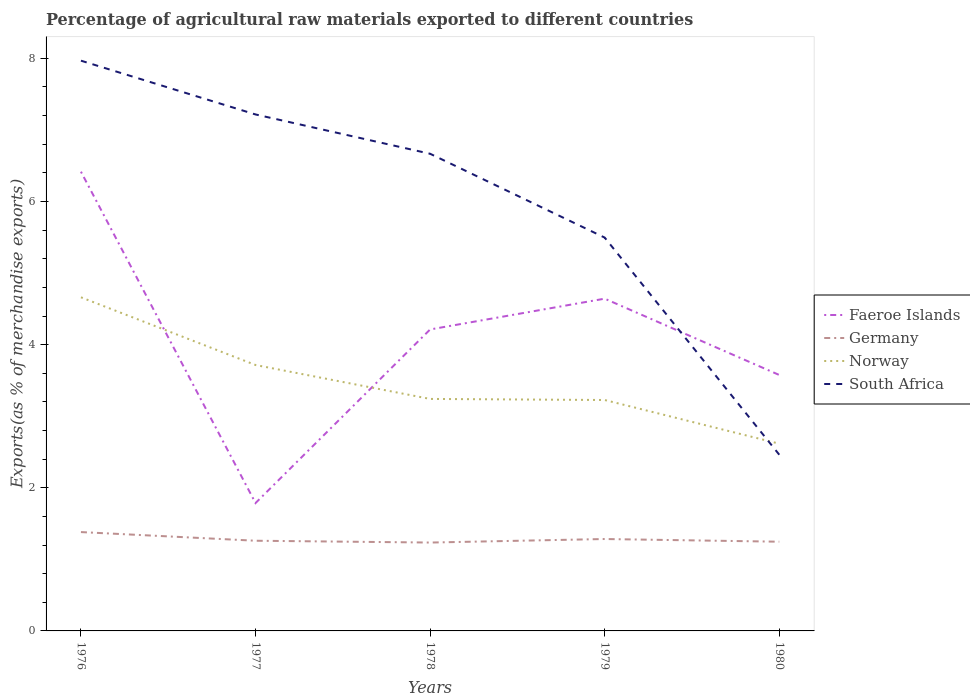How many different coloured lines are there?
Ensure brevity in your answer.  4. Is the number of lines equal to the number of legend labels?
Make the answer very short. Yes. Across all years, what is the maximum percentage of exports to different countries in Germany?
Keep it short and to the point. 1.23. What is the total percentage of exports to different countries in Germany in the graph?
Offer a terse response. -0.05. What is the difference between the highest and the second highest percentage of exports to different countries in Germany?
Offer a very short reply. 0.15. How many lines are there?
Give a very brief answer. 4. How many years are there in the graph?
Provide a succinct answer. 5. Where does the legend appear in the graph?
Offer a very short reply. Center right. How many legend labels are there?
Offer a very short reply. 4. How are the legend labels stacked?
Give a very brief answer. Vertical. What is the title of the graph?
Keep it short and to the point. Percentage of agricultural raw materials exported to different countries. What is the label or title of the X-axis?
Give a very brief answer. Years. What is the label or title of the Y-axis?
Provide a succinct answer. Exports(as % of merchandise exports). What is the Exports(as % of merchandise exports) of Faeroe Islands in 1976?
Your answer should be compact. 6.42. What is the Exports(as % of merchandise exports) of Germany in 1976?
Provide a short and direct response. 1.38. What is the Exports(as % of merchandise exports) in Norway in 1976?
Provide a succinct answer. 4.66. What is the Exports(as % of merchandise exports) of South Africa in 1976?
Offer a very short reply. 7.97. What is the Exports(as % of merchandise exports) of Faeroe Islands in 1977?
Keep it short and to the point. 1.79. What is the Exports(as % of merchandise exports) in Germany in 1977?
Your answer should be compact. 1.26. What is the Exports(as % of merchandise exports) in Norway in 1977?
Your answer should be very brief. 3.72. What is the Exports(as % of merchandise exports) in South Africa in 1977?
Your answer should be very brief. 7.22. What is the Exports(as % of merchandise exports) in Faeroe Islands in 1978?
Provide a succinct answer. 4.21. What is the Exports(as % of merchandise exports) of Germany in 1978?
Your answer should be compact. 1.23. What is the Exports(as % of merchandise exports) of Norway in 1978?
Make the answer very short. 3.24. What is the Exports(as % of merchandise exports) in South Africa in 1978?
Offer a terse response. 6.67. What is the Exports(as % of merchandise exports) in Faeroe Islands in 1979?
Your answer should be compact. 4.64. What is the Exports(as % of merchandise exports) of Germany in 1979?
Your answer should be very brief. 1.28. What is the Exports(as % of merchandise exports) of Norway in 1979?
Offer a terse response. 3.23. What is the Exports(as % of merchandise exports) of South Africa in 1979?
Provide a short and direct response. 5.5. What is the Exports(as % of merchandise exports) in Faeroe Islands in 1980?
Your answer should be very brief. 3.58. What is the Exports(as % of merchandise exports) in Germany in 1980?
Offer a terse response. 1.25. What is the Exports(as % of merchandise exports) in Norway in 1980?
Provide a short and direct response. 2.62. What is the Exports(as % of merchandise exports) in South Africa in 1980?
Your answer should be very brief. 2.46. Across all years, what is the maximum Exports(as % of merchandise exports) of Faeroe Islands?
Give a very brief answer. 6.42. Across all years, what is the maximum Exports(as % of merchandise exports) of Germany?
Your answer should be very brief. 1.38. Across all years, what is the maximum Exports(as % of merchandise exports) in Norway?
Ensure brevity in your answer.  4.66. Across all years, what is the maximum Exports(as % of merchandise exports) in South Africa?
Provide a succinct answer. 7.97. Across all years, what is the minimum Exports(as % of merchandise exports) of Faeroe Islands?
Provide a short and direct response. 1.79. Across all years, what is the minimum Exports(as % of merchandise exports) of Germany?
Offer a very short reply. 1.23. Across all years, what is the minimum Exports(as % of merchandise exports) in Norway?
Make the answer very short. 2.62. Across all years, what is the minimum Exports(as % of merchandise exports) of South Africa?
Provide a succinct answer. 2.46. What is the total Exports(as % of merchandise exports) of Faeroe Islands in the graph?
Your response must be concise. 20.63. What is the total Exports(as % of merchandise exports) in Germany in the graph?
Give a very brief answer. 6.41. What is the total Exports(as % of merchandise exports) in Norway in the graph?
Provide a succinct answer. 17.46. What is the total Exports(as % of merchandise exports) in South Africa in the graph?
Give a very brief answer. 29.81. What is the difference between the Exports(as % of merchandise exports) in Faeroe Islands in 1976 and that in 1977?
Offer a terse response. 4.63. What is the difference between the Exports(as % of merchandise exports) of Germany in 1976 and that in 1977?
Keep it short and to the point. 0.12. What is the difference between the Exports(as % of merchandise exports) of Norway in 1976 and that in 1977?
Offer a terse response. 0.95. What is the difference between the Exports(as % of merchandise exports) in South Africa in 1976 and that in 1977?
Your response must be concise. 0.75. What is the difference between the Exports(as % of merchandise exports) of Faeroe Islands in 1976 and that in 1978?
Give a very brief answer. 2.2. What is the difference between the Exports(as % of merchandise exports) of Germany in 1976 and that in 1978?
Give a very brief answer. 0.15. What is the difference between the Exports(as % of merchandise exports) in Norway in 1976 and that in 1978?
Offer a terse response. 1.42. What is the difference between the Exports(as % of merchandise exports) in South Africa in 1976 and that in 1978?
Provide a succinct answer. 1.3. What is the difference between the Exports(as % of merchandise exports) of Faeroe Islands in 1976 and that in 1979?
Make the answer very short. 1.77. What is the difference between the Exports(as % of merchandise exports) of Germany in 1976 and that in 1979?
Give a very brief answer. 0.1. What is the difference between the Exports(as % of merchandise exports) in Norway in 1976 and that in 1979?
Provide a succinct answer. 1.44. What is the difference between the Exports(as % of merchandise exports) of South Africa in 1976 and that in 1979?
Keep it short and to the point. 2.47. What is the difference between the Exports(as % of merchandise exports) in Faeroe Islands in 1976 and that in 1980?
Give a very brief answer. 2.84. What is the difference between the Exports(as % of merchandise exports) in Germany in 1976 and that in 1980?
Provide a succinct answer. 0.13. What is the difference between the Exports(as % of merchandise exports) in Norway in 1976 and that in 1980?
Your response must be concise. 2.05. What is the difference between the Exports(as % of merchandise exports) in South Africa in 1976 and that in 1980?
Your answer should be compact. 5.51. What is the difference between the Exports(as % of merchandise exports) of Faeroe Islands in 1977 and that in 1978?
Your answer should be compact. -2.43. What is the difference between the Exports(as % of merchandise exports) in Germany in 1977 and that in 1978?
Keep it short and to the point. 0.03. What is the difference between the Exports(as % of merchandise exports) of Norway in 1977 and that in 1978?
Provide a succinct answer. 0.47. What is the difference between the Exports(as % of merchandise exports) of South Africa in 1977 and that in 1978?
Your answer should be very brief. 0.55. What is the difference between the Exports(as % of merchandise exports) in Faeroe Islands in 1977 and that in 1979?
Your answer should be compact. -2.86. What is the difference between the Exports(as % of merchandise exports) in Germany in 1977 and that in 1979?
Your response must be concise. -0.02. What is the difference between the Exports(as % of merchandise exports) in Norway in 1977 and that in 1979?
Offer a very short reply. 0.49. What is the difference between the Exports(as % of merchandise exports) in South Africa in 1977 and that in 1979?
Offer a terse response. 1.72. What is the difference between the Exports(as % of merchandise exports) of Faeroe Islands in 1977 and that in 1980?
Your answer should be compact. -1.79. What is the difference between the Exports(as % of merchandise exports) in Germany in 1977 and that in 1980?
Offer a terse response. 0.01. What is the difference between the Exports(as % of merchandise exports) in Norway in 1977 and that in 1980?
Provide a succinct answer. 1.1. What is the difference between the Exports(as % of merchandise exports) in South Africa in 1977 and that in 1980?
Provide a succinct answer. 4.75. What is the difference between the Exports(as % of merchandise exports) of Faeroe Islands in 1978 and that in 1979?
Keep it short and to the point. -0.43. What is the difference between the Exports(as % of merchandise exports) in Germany in 1978 and that in 1979?
Keep it short and to the point. -0.05. What is the difference between the Exports(as % of merchandise exports) in Norway in 1978 and that in 1979?
Make the answer very short. 0.02. What is the difference between the Exports(as % of merchandise exports) of South Africa in 1978 and that in 1979?
Your answer should be compact. 1.17. What is the difference between the Exports(as % of merchandise exports) of Faeroe Islands in 1978 and that in 1980?
Give a very brief answer. 0.64. What is the difference between the Exports(as % of merchandise exports) of Germany in 1978 and that in 1980?
Your answer should be compact. -0.01. What is the difference between the Exports(as % of merchandise exports) in Norway in 1978 and that in 1980?
Your answer should be very brief. 0.63. What is the difference between the Exports(as % of merchandise exports) in South Africa in 1978 and that in 1980?
Give a very brief answer. 4.21. What is the difference between the Exports(as % of merchandise exports) in Faeroe Islands in 1979 and that in 1980?
Your answer should be very brief. 1.07. What is the difference between the Exports(as % of merchandise exports) in Germany in 1979 and that in 1980?
Make the answer very short. 0.04. What is the difference between the Exports(as % of merchandise exports) of Norway in 1979 and that in 1980?
Give a very brief answer. 0.61. What is the difference between the Exports(as % of merchandise exports) of South Africa in 1979 and that in 1980?
Offer a very short reply. 3.03. What is the difference between the Exports(as % of merchandise exports) in Faeroe Islands in 1976 and the Exports(as % of merchandise exports) in Germany in 1977?
Your answer should be compact. 5.16. What is the difference between the Exports(as % of merchandise exports) of Faeroe Islands in 1976 and the Exports(as % of merchandise exports) of Norway in 1977?
Provide a short and direct response. 2.7. What is the difference between the Exports(as % of merchandise exports) in Faeroe Islands in 1976 and the Exports(as % of merchandise exports) in South Africa in 1977?
Provide a short and direct response. -0.8. What is the difference between the Exports(as % of merchandise exports) in Germany in 1976 and the Exports(as % of merchandise exports) in Norway in 1977?
Your answer should be compact. -2.33. What is the difference between the Exports(as % of merchandise exports) in Germany in 1976 and the Exports(as % of merchandise exports) in South Africa in 1977?
Your response must be concise. -5.84. What is the difference between the Exports(as % of merchandise exports) of Norway in 1976 and the Exports(as % of merchandise exports) of South Africa in 1977?
Offer a terse response. -2.55. What is the difference between the Exports(as % of merchandise exports) of Faeroe Islands in 1976 and the Exports(as % of merchandise exports) of Germany in 1978?
Your answer should be very brief. 5.18. What is the difference between the Exports(as % of merchandise exports) in Faeroe Islands in 1976 and the Exports(as % of merchandise exports) in Norway in 1978?
Offer a very short reply. 3.17. What is the difference between the Exports(as % of merchandise exports) in Faeroe Islands in 1976 and the Exports(as % of merchandise exports) in South Africa in 1978?
Keep it short and to the point. -0.25. What is the difference between the Exports(as % of merchandise exports) in Germany in 1976 and the Exports(as % of merchandise exports) in Norway in 1978?
Give a very brief answer. -1.86. What is the difference between the Exports(as % of merchandise exports) of Germany in 1976 and the Exports(as % of merchandise exports) of South Africa in 1978?
Your response must be concise. -5.29. What is the difference between the Exports(as % of merchandise exports) of Norway in 1976 and the Exports(as % of merchandise exports) of South Africa in 1978?
Provide a succinct answer. -2.01. What is the difference between the Exports(as % of merchandise exports) of Faeroe Islands in 1976 and the Exports(as % of merchandise exports) of Germany in 1979?
Provide a short and direct response. 5.13. What is the difference between the Exports(as % of merchandise exports) in Faeroe Islands in 1976 and the Exports(as % of merchandise exports) in Norway in 1979?
Your response must be concise. 3.19. What is the difference between the Exports(as % of merchandise exports) in Faeroe Islands in 1976 and the Exports(as % of merchandise exports) in South Africa in 1979?
Your response must be concise. 0.92. What is the difference between the Exports(as % of merchandise exports) of Germany in 1976 and the Exports(as % of merchandise exports) of Norway in 1979?
Make the answer very short. -1.85. What is the difference between the Exports(as % of merchandise exports) of Germany in 1976 and the Exports(as % of merchandise exports) of South Africa in 1979?
Give a very brief answer. -4.11. What is the difference between the Exports(as % of merchandise exports) of Norway in 1976 and the Exports(as % of merchandise exports) of South Africa in 1979?
Ensure brevity in your answer.  -0.83. What is the difference between the Exports(as % of merchandise exports) in Faeroe Islands in 1976 and the Exports(as % of merchandise exports) in Germany in 1980?
Ensure brevity in your answer.  5.17. What is the difference between the Exports(as % of merchandise exports) in Faeroe Islands in 1976 and the Exports(as % of merchandise exports) in Norway in 1980?
Keep it short and to the point. 3.8. What is the difference between the Exports(as % of merchandise exports) of Faeroe Islands in 1976 and the Exports(as % of merchandise exports) of South Africa in 1980?
Make the answer very short. 3.95. What is the difference between the Exports(as % of merchandise exports) in Germany in 1976 and the Exports(as % of merchandise exports) in Norway in 1980?
Ensure brevity in your answer.  -1.24. What is the difference between the Exports(as % of merchandise exports) in Germany in 1976 and the Exports(as % of merchandise exports) in South Africa in 1980?
Your answer should be compact. -1.08. What is the difference between the Exports(as % of merchandise exports) in Norway in 1976 and the Exports(as % of merchandise exports) in South Africa in 1980?
Provide a short and direct response. 2.2. What is the difference between the Exports(as % of merchandise exports) of Faeroe Islands in 1977 and the Exports(as % of merchandise exports) of Germany in 1978?
Keep it short and to the point. 0.55. What is the difference between the Exports(as % of merchandise exports) of Faeroe Islands in 1977 and the Exports(as % of merchandise exports) of Norway in 1978?
Your response must be concise. -1.45. What is the difference between the Exports(as % of merchandise exports) in Faeroe Islands in 1977 and the Exports(as % of merchandise exports) in South Africa in 1978?
Make the answer very short. -4.88. What is the difference between the Exports(as % of merchandise exports) in Germany in 1977 and the Exports(as % of merchandise exports) in Norway in 1978?
Ensure brevity in your answer.  -1.98. What is the difference between the Exports(as % of merchandise exports) of Germany in 1977 and the Exports(as % of merchandise exports) of South Africa in 1978?
Your answer should be very brief. -5.41. What is the difference between the Exports(as % of merchandise exports) in Norway in 1977 and the Exports(as % of merchandise exports) in South Africa in 1978?
Provide a succinct answer. -2.95. What is the difference between the Exports(as % of merchandise exports) in Faeroe Islands in 1977 and the Exports(as % of merchandise exports) in Germany in 1979?
Your answer should be very brief. 0.5. What is the difference between the Exports(as % of merchandise exports) of Faeroe Islands in 1977 and the Exports(as % of merchandise exports) of Norway in 1979?
Offer a terse response. -1.44. What is the difference between the Exports(as % of merchandise exports) of Faeroe Islands in 1977 and the Exports(as % of merchandise exports) of South Africa in 1979?
Make the answer very short. -3.71. What is the difference between the Exports(as % of merchandise exports) in Germany in 1977 and the Exports(as % of merchandise exports) in Norway in 1979?
Keep it short and to the point. -1.97. What is the difference between the Exports(as % of merchandise exports) of Germany in 1977 and the Exports(as % of merchandise exports) of South Africa in 1979?
Give a very brief answer. -4.24. What is the difference between the Exports(as % of merchandise exports) of Norway in 1977 and the Exports(as % of merchandise exports) of South Africa in 1979?
Your answer should be compact. -1.78. What is the difference between the Exports(as % of merchandise exports) of Faeroe Islands in 1977 and the Exports(as % of merchandise exports) of Germany in 1980?
Offer a very short reply. 0.54. What is the difference between the Exports(as % of merchandise exports) in Faeroe Islands in 1977 and the Exports(as % of merchandise exports) in Norway in 1980?
Provide a short and direct response. -0.83. What is the difference between the Exports(as % of merchandise exports) of Faeroe Islands in 1977 and the Exports(as % of merchandise exports) of South Africa in 1980?
Give a very brief answer. -0.68. What is the difference between the Exports(as % of merchandise exports) in Germany in 1977 and the Exports(as % of merchandise exports) in Norway in 1980?
Your answer should be compact. -1.36. What is the difference between the Exports(as % of merchandise exports) in Germany in 1977 and the Exports(as % of merchandise exports) in South Africa in 1980?
Make the answer very short. -1.2. What is the difference between the Exports(as % of merchandise exports) in Norway in 1977 and the Exports(as % of merchandise exports) in South Africa in 1980?
Provide a succinct answer. 1.25. What is the difference between the Exports(as % of merchandise exports) in Faeroe Islands in 1978 and the Exports(as % of merchandise exports) in Germany in 1979?
Offer a terse response. 2.93. What is the difference between the Exports(as % of merchandise exports) of Faeroe Islands in 1978 and the Exports(as % of merchandise exports) of Norway in 1979?
Make the answer very short. 0.99. What is the difference between the Exports(as % of merchandise exports) in Faeroe Islands in 1978 and the Exports(as % of merchandise exports) in South Africa in 1979?
Ensure brevity in your answer.  -1.28. What is the difference between the Exports(as % of merchandise exports) in Germany in 1978 and the Exports(as % of merchandise exports) in Norway in 1979?
Make the answer very short. -1.99. What is the difference between the Exports(as % of merchandise exports) of Germany in 1978 and the Exports(as % of merchandise exports) of South Africa in 1979?
Your response must be concise. -4.26. What is the difference between the Exports(as % of merchandise exports) in Norway in 1978 and the Exports(as % of merchandise exports) in South Africa in 1979?
Ensure brevity in your answer.  -2.25. What is the difference between the Exports(as % of merchandise exports) in Faeroe Islands in 1978 and the Exports(as % of merchandise exports) in Germany in 1980?
Provide a short and direct response. 2.97. What is the difference between the Exports(as % of merchandise exports) of Faeroe Islands in 1978 and the Exports(as % of merchandise exports) of Norway in 1980?
Provide a succinct answer. 1.6. What is the difference between the Exports(as % of merchandise exports) of Faeroe Islands in 1978 and the Exports(as % of merchandise exports) of South Africa in 1980?
Ensure brevity in your answer.  1.75. What is the difference between the Exports(as % of merchandise exports) in Germany in 1978 and the Exports(as % of merchandise exports) in Norway in 1980?
Offer a terse response. -1.38. What is the difference between the Exports(as % of merchandise exports) of Germany in 1978 and the Exports(as % of merchandise exports) of South Africa in 1980?
Provide a short and direct response. -1.23. What is the difference between the Exports(as % of merchandise exports) of Norway in 1978 and the Exports(as % of merchandise exports) of South Africa in 1980?
Give a very brief answer. 0.78. What is the difference between the Exports(as % of merchandise exports) in Faeroe Islands in 1979 and the Exports(as % of merchandise exports) in Germany in 1980?
Your answer should be compact. 3.4. What is the difference between the Exports(as % of merchandise exports) in Faeroe Islands in 1979 and the Exports(as % of merchandise exports) in Norway in 1980?
Your answer should be very brief. 2.03. What is the difference between the Exports(as % of merchandise exports) in Faeroe Islands in 1979 and the Exports(as % of merchandise exports) in South Africa in 1980?
Offer a very short reply. 2.18. What is the difference between the Exports(as % of merchandise exports) in Germany in 1979 and the Exports(as % of merchandise exports) in Norway in 1980?
Your answer should be very brief. -1.33. What is the difference between the Exports(as % of merchandise exports) of Germany in 1979 and the Exports(as % of merchandise exports) of South Africa in 1980?
Your answer should be compact. -1.18. What is the difference between the Exports(as % of merchandise exports) in Norway in 1979 and the Exports(as % of merchandise exports) in South Africa in 1980?
Provide a succinct answer. 0.76. What is the average Exports(as % of merchandise exports) in Faeroe Islands per year?
Make the answer very short. 4.13. What is the average Exports(as % of merchandise exports) of Germany per year?
Offer a very short reply. 1.28. What is the average Exports(as % of merchandise exports) of Norway per year?
Your response must be concise. 3.49. What is the average Exports(as % of merchandise exports) of South Africa per year?
Your response must be concise. 5.96. In the year 1976, what is the difference between the Exports(as % of merchandise exports) of Faeroe Islands and Exports(as % of merchandise exports) of Germany?
Keep it short and to the point. 5.04. In the year 1976, what is the difference between the Exports(as % of merchandise exports) of Faeroe Islands and Exports(as % of merchandise exports) of Norway?
Your answer should be very brief. 1.75. In the year 1976, what is the difference between the Exports(as % of merchandise exports) of Faeroe Islands and Exports(as % of merchandise exports) of South Africa?
Provide a short and direct response. -1.55. In the year 1976, what is the difference between the Exports(as % of merchandise exports) of Germany and Exports(as % of merchandise exports) of Norway?
Provide a short and direct response. -3.28. In the year 1976, what is the difference between the Exports(as % of merchandise exports) in Germany and Exports(as % of merchandise exports) in South Africa?
Your answer should be very brief. -6.59. In the year 1976, what is the difference between the Exports(as % of merchandise exports) of Norway and Exports(as % of merchandise exports) of South Africa?
Make the answer very short. -3.31. In the year 1977, what is the difference between the Exports(as % of merchandise exports) of Faeroe Islands and Exports(as % of merchandise exports) of Germany?
Offer a terse response. 0.53. In the year 1977, what is the difference between the Exports(as % of merchandise exports) of Faeroe Islands and Exports(as % of merchandise exports) of Norway?
Offer a terse response. -1.93. In the year 1977, what is the difference between the Exports(as % of merchandise exports) of Faeroe Islands and Exports(as % of merchandise exports) of South Africa?
Ensure brevity in your answer.  -5.43. In the year 1977, what is the difference between the Exports(as % of merchandise exports) in Germany and Exports(as % of merchandise exports) in Norway?
Provide a succinct answer. -2.46. In the year 1977, what is the difference between the Exports(as % of merchandise exports) in Germany and Exports(as % of merchandise exports) in South Africa?
Your response must be concise. -5.96. In the year 1977, what is the difference between the Exports(as % of merchandise exports) of Norway and Exports(as % of merchandise exports) of South Africa?
Provide a short and direct response. -3.5. In the year 1978, what is the difference between the Exports(as % of merchandise exports) in Faeroe Islands and Exports(as % of merchandise exports) in Germany?
Provide a short and direct response. 2.98. In the year 1978, what is the difference between the Exports(as % of merchandise exports) in Faeroe Islands and Exports(as % of merchandise exports) in Norway?
Ensure brevity in your answer.  0.97. In the year 1978, what is the difference between the Exports(as % of merchandise exports) of Faeroe Islands and Exports(as % of merchandise exports) of South Africa?
Keep it short and to the point. -2.45. In the year 1978, what is the difference between the Exports(as % of merchandise exports) of Germany and Exports(as % of merchandise exports) of Norway?
Provide a succinct answer. -2.01. In the year 1978, what is the difference between the Exports(as % of merchandise exports) of Germany and Exports(as % of merchandise exports) of South Africa?
Provide a succinct answer. -5.43. In the year 1978, what is the difference between the Exports(as % of merchandise exports) in Norway and Exports(as % of merchandise exports) in South Africa?
Your answer should be very brief. -3.43. In the year 1979, what is the difference between the Exports(as % of merchandise exports) in Faeroe Islands and Exports(as % of merchandise exports) in Germany?
Give a very brief answer. 3.36. In the year 1979, what is the difference between the Exports(as % of merchandise exports) of Faeroe Islands and Exports(as % of merchandise exports) of Norway?
Keep it short and to the point. 1.42. In the year 1979, what is the difference between the Exports(as % of merchandise exports) in Faeroe Islands and Exports(as % of merchandise exports) in South Africa?
Provide a succinct answer. -0.85. In the year 1979, what is the difference between the Exports(as % of merchandise exports) of Germany and Exports(as % of merchandise exports) of Norway?
Give a very brief answer. -1.94. In the year 1979, what is the difference between the Exports(as % of merchandise exports) in Germany and Exports(as % of merchandise exports) in South Africa?
Your answer should be compact. -4.21. In the year 1979, what is the difference between the Exports(as % of merchandise exports) of Norway and Exports(as % of merchandise exports) of South Africa?
Give a very brief answer. -2.27. In the year 1980, what is the difference between the Exports(as % of merchandise exports) of Faeroe Islands and Exports(as % of merchandise exports) of Germany?
Provide a short and direct response. 2.33. In the year 1980, what is the difference between the Exports(as % of merchandise exports) of Faeroe Islands and Exports(as % of merchandise exports) of Norway?
Your answer should be very brief. 0.96. In the year 1980, what is the difference between the Exports(as % of merchandise exports) of Faeroe Islands and Exports(as % of merchandise exports) of South Africa?
Provide a succinct answer. 1.11. In the year 1980, what is the difference between the Exports(as % of merchandise exports) in Germany and Exports(as % of merchandise exports) in Norway?
Make the answer very short. -1.37. In the year 1980, what is the difference between the Exports(as % of merchandise exports) of Germany and Exports(as % of merchandise exports) of South Africa?
Your response must be concise. -1.22. In the year 1980, what is the difference between the Exports(as % of merchandise exports) of Norway and Exports(as % of merchandise exports) of South Africa?
Your response must be concise. 0.15. What is the ratio of the Exports(as % of merchandise exports) in Faeroe Islands in 1976 to that in 1977?
Keep it short and to the point. 3.59. What is the ratio of the Exports(as % of merchandise exports) of Germany in 1976 to that in 1977?
Provide a short and direct response. 1.1. What is the ratio of the Exports(as % of merchandise exports) in Norway in 1976 to that in 1977?
Offer a very short reply. 1.25. What is the ratio of the Exports(as % of merchandise exports) in South Africa in 1976 to that in 1977?
Your answer should be compact. 1.1. What is the ratio of the Exports(as % of merchandise exports) of Faeroe Islands in 1976 to that in 1978?
Your answer should be very brief. 1.52. What is the ratio of the Exports(as % of merchandise exports) in Germany in 1976 to that in 1978?
Your answer should be compact. 1.12. What is the ratio of the Exports(as % of merchandise exports) in Norway in 1976 to that in 1978?
Make the answer very short. 1.44. What is the ratio of the Exports(as % of merchandise exports) of South Africa in 1976 to that in 1978?
Your answer should be compact. 1.2. What is the ratio of the Exports(as % of merchandise exports) of Faeroe Islands in 1976 to that in 1979?
Make the answer very short. 1.38. What is the ratio of the Exports(as % of merchandise exports) of Germany in 1976 to that in 1979?
Provide a short and direct response. 1.08. What is the ratio of the Exports(as % of merchandise exports) in Norway in 1976 to that in 1979?
Your answer should be compact. 1.44. What is the ratio of the Exports(as % of merchandise exports) of South Africa in 1976 to that in 1979?
Make the answer very short. 1.45. What is the ratio of the Exports(as % of merchandise exports) in Faeroe Islands in 1976 to that in 1980?
Keep it short and to the point. 1.79. What is the ratio of the Exports(as % of merchandise exports) of Germany in 1976 to that in 1980?
Your answer should be compact. 1.11. What is the ratio of the Exports(as % of merchandise exports) in Norway in 1976 to that in 1980?
Your response must be concise. 1.78. What is the ratio of the Exports(as % of merchandise exports) in South Africa in 1976 to that in 1980?
Your answer should be compact. 3.24. What is the ratio of the Exports(as % of merchandise exports) of Faeroe Islands in 1977 to that in 1978?
Offer a very short reply. 0.42. What is the ratio of the Exports(as % of merchandise exports) in Germany in 1977 to that in 1978?
Your response must be concise. 1.02. What is the ratio of the Exports(as % of merchandise exports) of Norway in 1977 to that in 1978?
Ensure brevity in your answer.  1.15. What is the ratio of the Exports(as % of merchandise exports) in South Africa in 1977 to that in 1978?
Provide a succinct answer. 1.08. What is the ratio of the Exports(as % of merchandise exports) in Faeroe Islands in 1977 to that in 1979?
Your response must be concise. 0.38. What is the ratio of the Exports(as % of merchandise exports) of Germany in 1977 to that in 1979?
Offer a terse response. 0.98. What is the ratio of the Exports(as % of merchandise exports) in Norway in 1977 to that in 1979?
Provide a succinct answer. 1.15. What is the ratio of the Exports(as % of merchandise exports) of South Africa in 1977 to that in 1979?
Your response must be concise. 1.31. What is the ratio of the Exports(as % of merchandise exports) in Faeroe Islands in 1977 to that in 1980?
Make the answer very short. 0.5. What is the ratio of the Exports(as % of merchandise exports) of Norway in 1977 to that in 1980?
Give a very brief answer. 1.42. What is the ratio of the Exports(as % of merchandise exports) in South Africa in 1977 to that in 1980?
Offer a terse response. 2.93. What is the ratio of the Exports(as % of merchandise exports) of Faeroe Islands in 1978 to that in 1979?
Make the answer very short. 0.91. What is the ratio of the Exports(as % of merchandise exports) of Germany in 1978 to that in 1979?
Ensure brevity in your answer.  0.96. What is the ratio of the Exports(as % of merchandise exports) of Norway in 1978 to that in 1979?
Give a very brief answer. 1. What is the ratio of the Exports(as % of merchandise exports) of South Africa in 1978 to that in 1979?
Your answer should be compact. 1.21. What is the ratio of the Exports(as % of merchandise exports) in Faeroe Islands in 1978 to that in 1980?
Offer a terse response. 1.18. What is the ratio of the Exports(as % of merchandise exports) of Germany in 1978 to that in 1980?
Give a very brief answer. 0.99. What is the ratio of the Exports(as % of merchandise exports) of Norway in 1978 to that in 1980?
Your response must be concise. 1.24. What is the ratio of the Exports(as % of merchandise exports) in South Africa in 1978 to that in 1980?
Ensure brevity in your answer.  2.71. What is the ratio of the Exports(as % of merchandise exports) of Faeroe Islands in 1979 to that in 1980?
Give a very brief answer. 1.3. What is the ratio of the Exports(as % of merchandise exports) of Germany in 1979 to that in 1980?
Your answer should be very brief. 1.03. What is the ratio of the Exports(as % of merchandise exports) in Norway in 1979 to that in 1980?
Your response must be concise. 1.23. What is the ratio of the Exports(as % of merchandise exports) of South Africa in 1979 to that in 1980?
Your answer should be very brief. 2.23. What is the difference between the highest and the second highest Exports(as % of merchandise exports) in Faeroe Islands?
Provide a short and direct response. 1.77. What is the difference between the highest and the second highest Exports(as % of merchandise exports) of Germany?
Give a very brief answer. 0.1. What is the difference between the highest and the second highest Exports(as % of merchandise exports) of Norway?
Your answer should be compact. 0.95. What is the difference between the highest and the second highest Exports(as % of merchandise exports) in South Africa?
Ensure brevity in your answer.  0.75. What is the difference between the highest and the lowest Exports(as % of merchandise exports) in Faeroe Islands?
Ensure brevity in your answer.  4.63. What is the difference between the highest and the lowest Exports(as % of merchandise exports) in Germany?
Give a very brief answer. 0.15. What is the difference between the highest and the lowest Exports(as % of merchandise exports) of Norway?
Your answer should be compact. 2.05. What is the difference between the highest and the lowest Exports(as % of merchandise exports) in South Africa?
Your response must be concise. 5.51. 